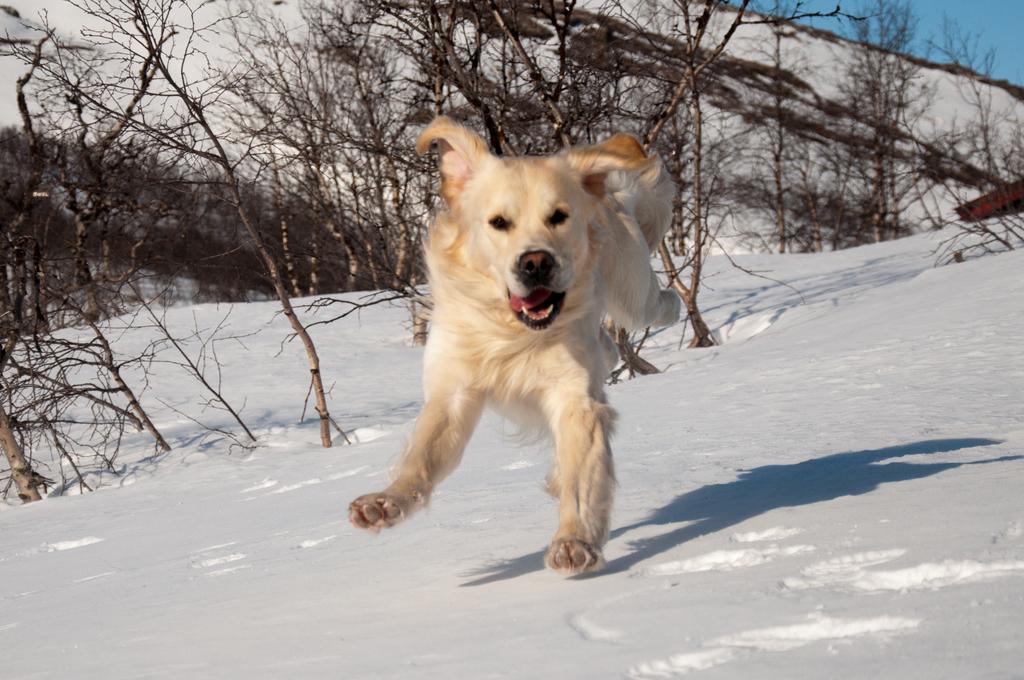How would you summarize this image in a sentence or two? In this image we can see an animal. And we can see the snow. And we can see the hill, dried trees and the sky. 